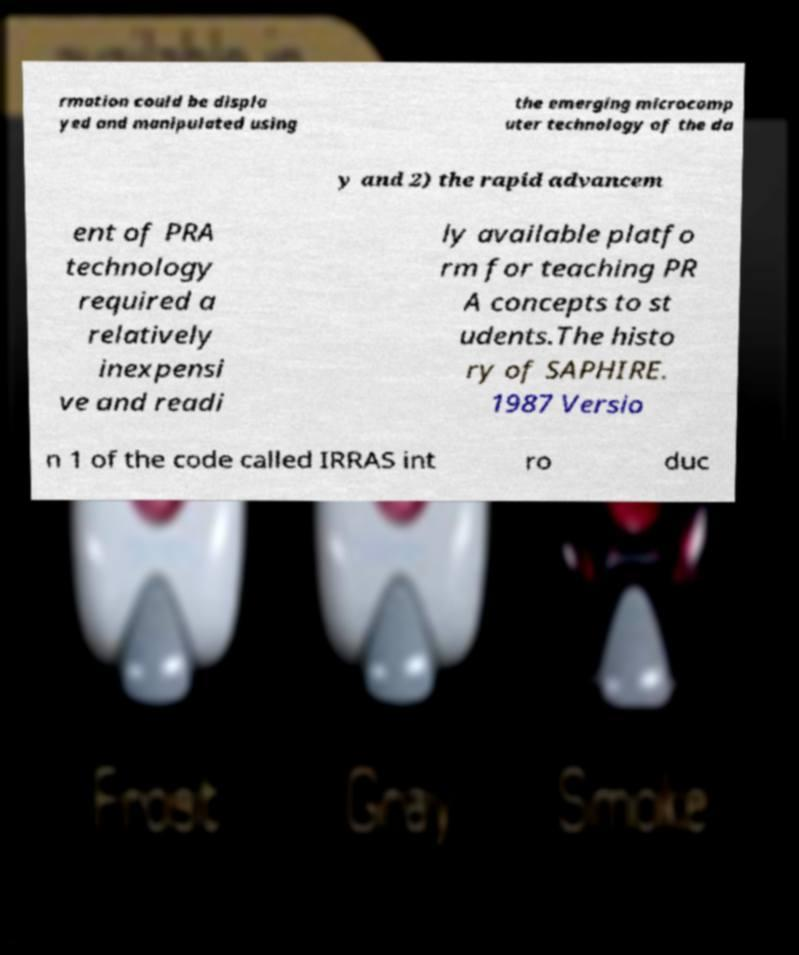For documentation purposes, I need the text within this image transcribed. Could you provide that? rmation could be displa yed and manipulated using the emerging microcomp uter technology of the da y and 2) the rapid advancem ent of PRA technology required a relatively inexpensi ve and readi ly available platfo rm for teaching PR A concepts to st udents.The histo ry of SAPHIRE. 1987 Versio n 1 of the code called IRRAS int ro duc 